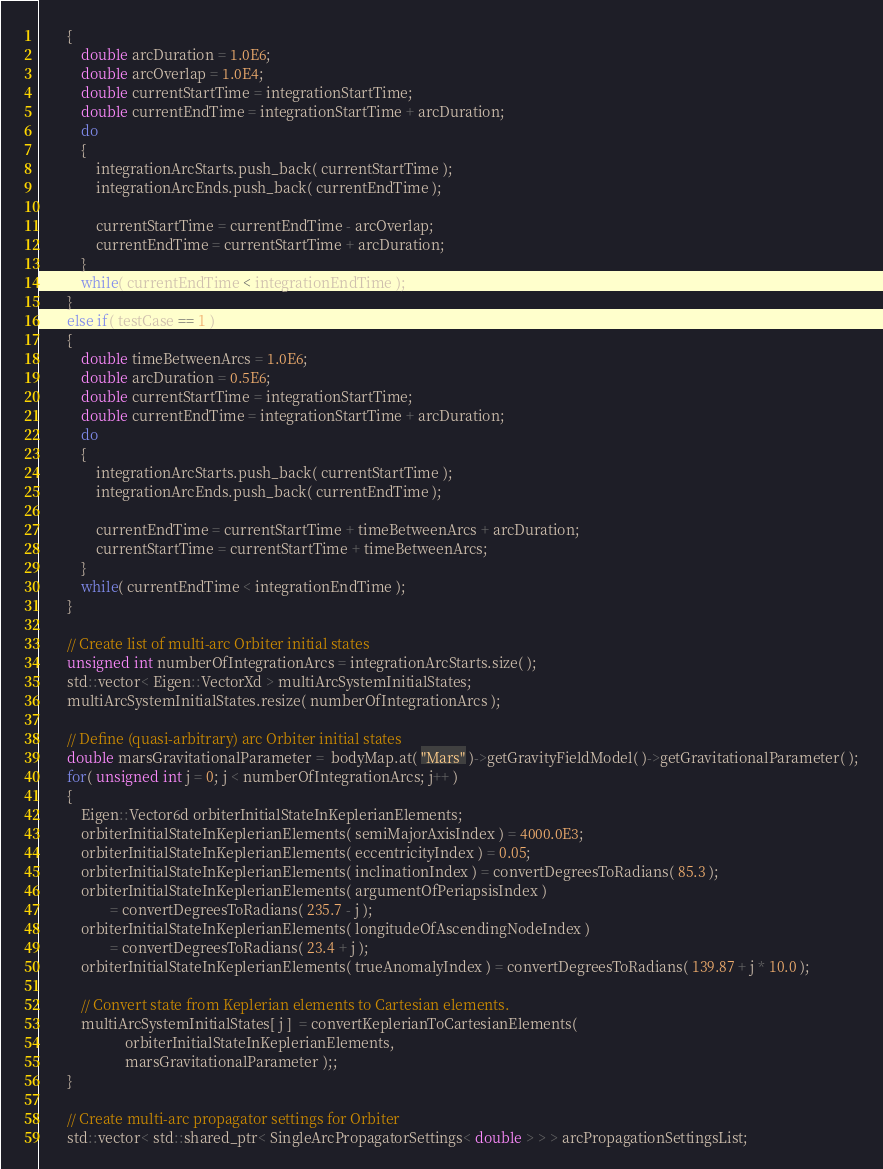<code> <loc_0><loc_0><loc_500><loc_500><_C++_>        {
            double arcDuration = 1.0E6;
            double arcOverlap = 1.0E4;
            double currentStartTime = integrationStartTime;
            double currentEndTime = integrationStartTime + arcDuration;
            do
            {
                integrationArcStarts.push_back( currentStartTime );
                integrationArcEnds.push_back( currentEndTime );

                currentStartTime = currentEndTime - arcOverlap;
                currentEndTime = currentStartTime + arcDuration;
            }
            while( currentEndTime < integrationEndTime );
        }
        else if( testCase == 1 )
        {
            double timeBetweenArcs = 1.0E6;
            double arcDuration = 0.5E6;
            double currentStartTime = integrationStartTime;
            double currentEndTime = integrationStartTime + arcDuration;
            do
            {
                integrationArcStarts.push_back( currentStartTime );
                integrationArcEnds.push_back( currentEndTime );

                currentEndTime = currentStartTime + timeBetweenArcs + arcDuration;
                currentStartTime = currentStartTime + timeBetweenArcs;
            }
            while( currentEndTime < integrationEndTime );
        }

        // Create list of multi-arc Orbiter initial states
        unsigned int numberOfIntegrationArcs = integrationArcStarts.size( );
        std::vector< Eigen::VectorXd > multiArcSystemInitialStates;
        multiArcSystemInitialStates.resize( numberOfIntegrationArcs );

        // Define (quasi-arbitrary) arc Orbiter initial states
        double marsGravitationalParameter =  bodyMap.at( "Mars" )->getGravityFieldModel( )->getGravitationalParameter( );
        for( unsigned int j = 0; j < numberOfIntegrationArcs; j++ )
        {
            Eigen::Vector6d orbiterInitialStateInKeplerianElements;
            orbiterInitialStateInKeplerianElements( semiMajorAxisIndex ) = 4000.0E3;
            orbiterInitialStateInKeplerianElements( eccentricityIndex ) = 0.05;
            orbiterInitialStateInKeplerianElements( inclinationIndex ) = convertDegreesToRadians( 85.3 );
            orbiterInitialStateInKeplerianElements( argumentOfPeriapsisIndex )
                    = convertDegreesToRadians( 235.7 - j );
            orbiterInitialStateInKeplerianElements( longitudeOfAscendingNodeIndex )
                    = convertDegreesToRadians( 23.4 + j );
            orbiterInitialStateInKeplerianElements( trueAnomalyIndex ) = convertDegreesToRadians( 139.87 + j * 10.0 );

            // Convert state from Keplerian elements to Cartesian elements.
            multiArcSystemInitialStates[ j ]  = convertKeplerianToCartesianElements(
                        orbiterInitialStateInKeplerianElements,
                        marsGravitationalParameter );;
        }

        // Create multi-arc propagator settings for Orbiter
        std::vector< std::shared_ptr< SingleArcPropagatorSettings< double > > > arcPropagationSettingsList;</code> 